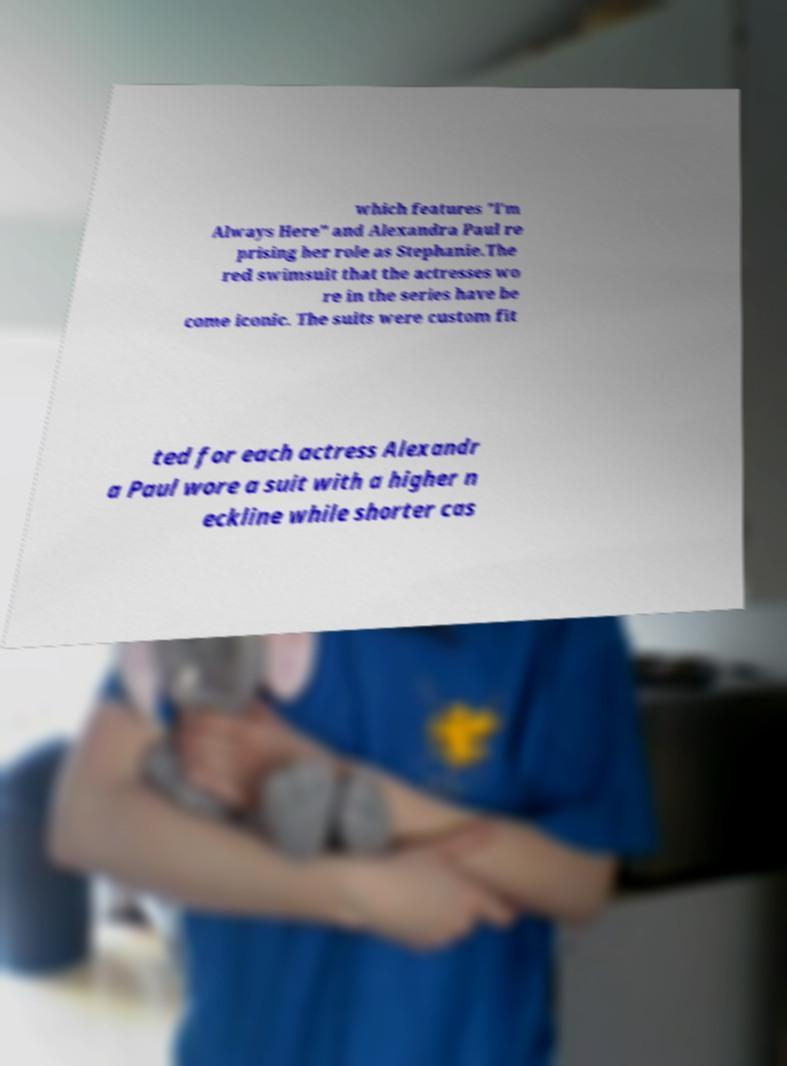Could you assist in decoding the text presented in this image and type it out clearly? which features "I'm Always Here" and Alexandra Paul re prising her role as Stephanie.The red swimsuit that the actresses wo re in the series have be come iconic. The suits were custom fit ted for each actress Alexandr a Paul wore a suit with a higher n eckline while shorter cas 